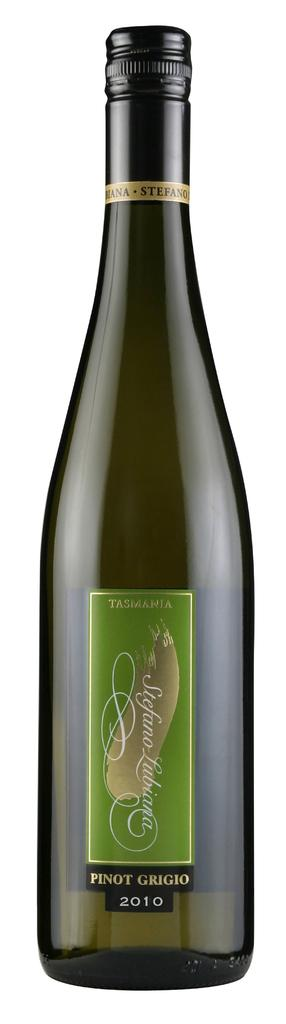<image>
Present a compact description of the photo's key features. A bottle of wine from Tasmania that says Pinot Grigio 2010. 